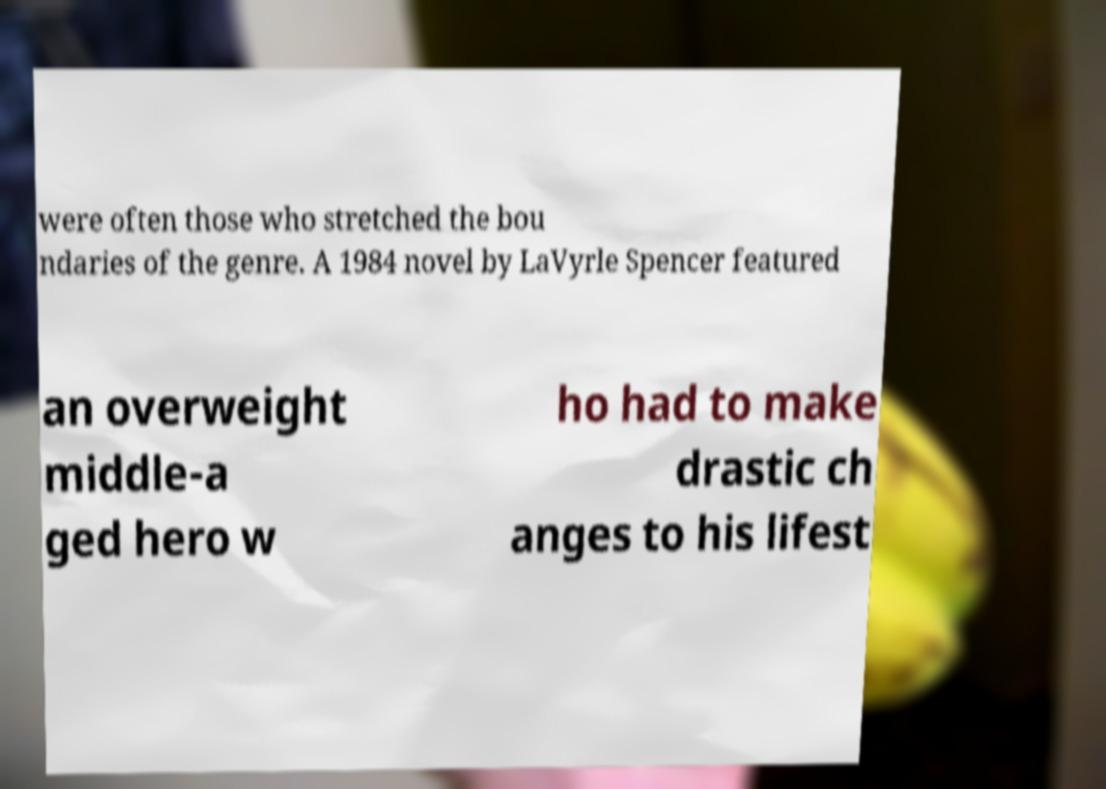There's text embedded in this image that I need extracted. Can you transcribe it verbatim? were often those who stretched the bou ndaries of the genre. A 1984 novel by LaVyrle Spencer featured an overweight middle-a ged hero w ho had to make drastic ch anges to his lifest 